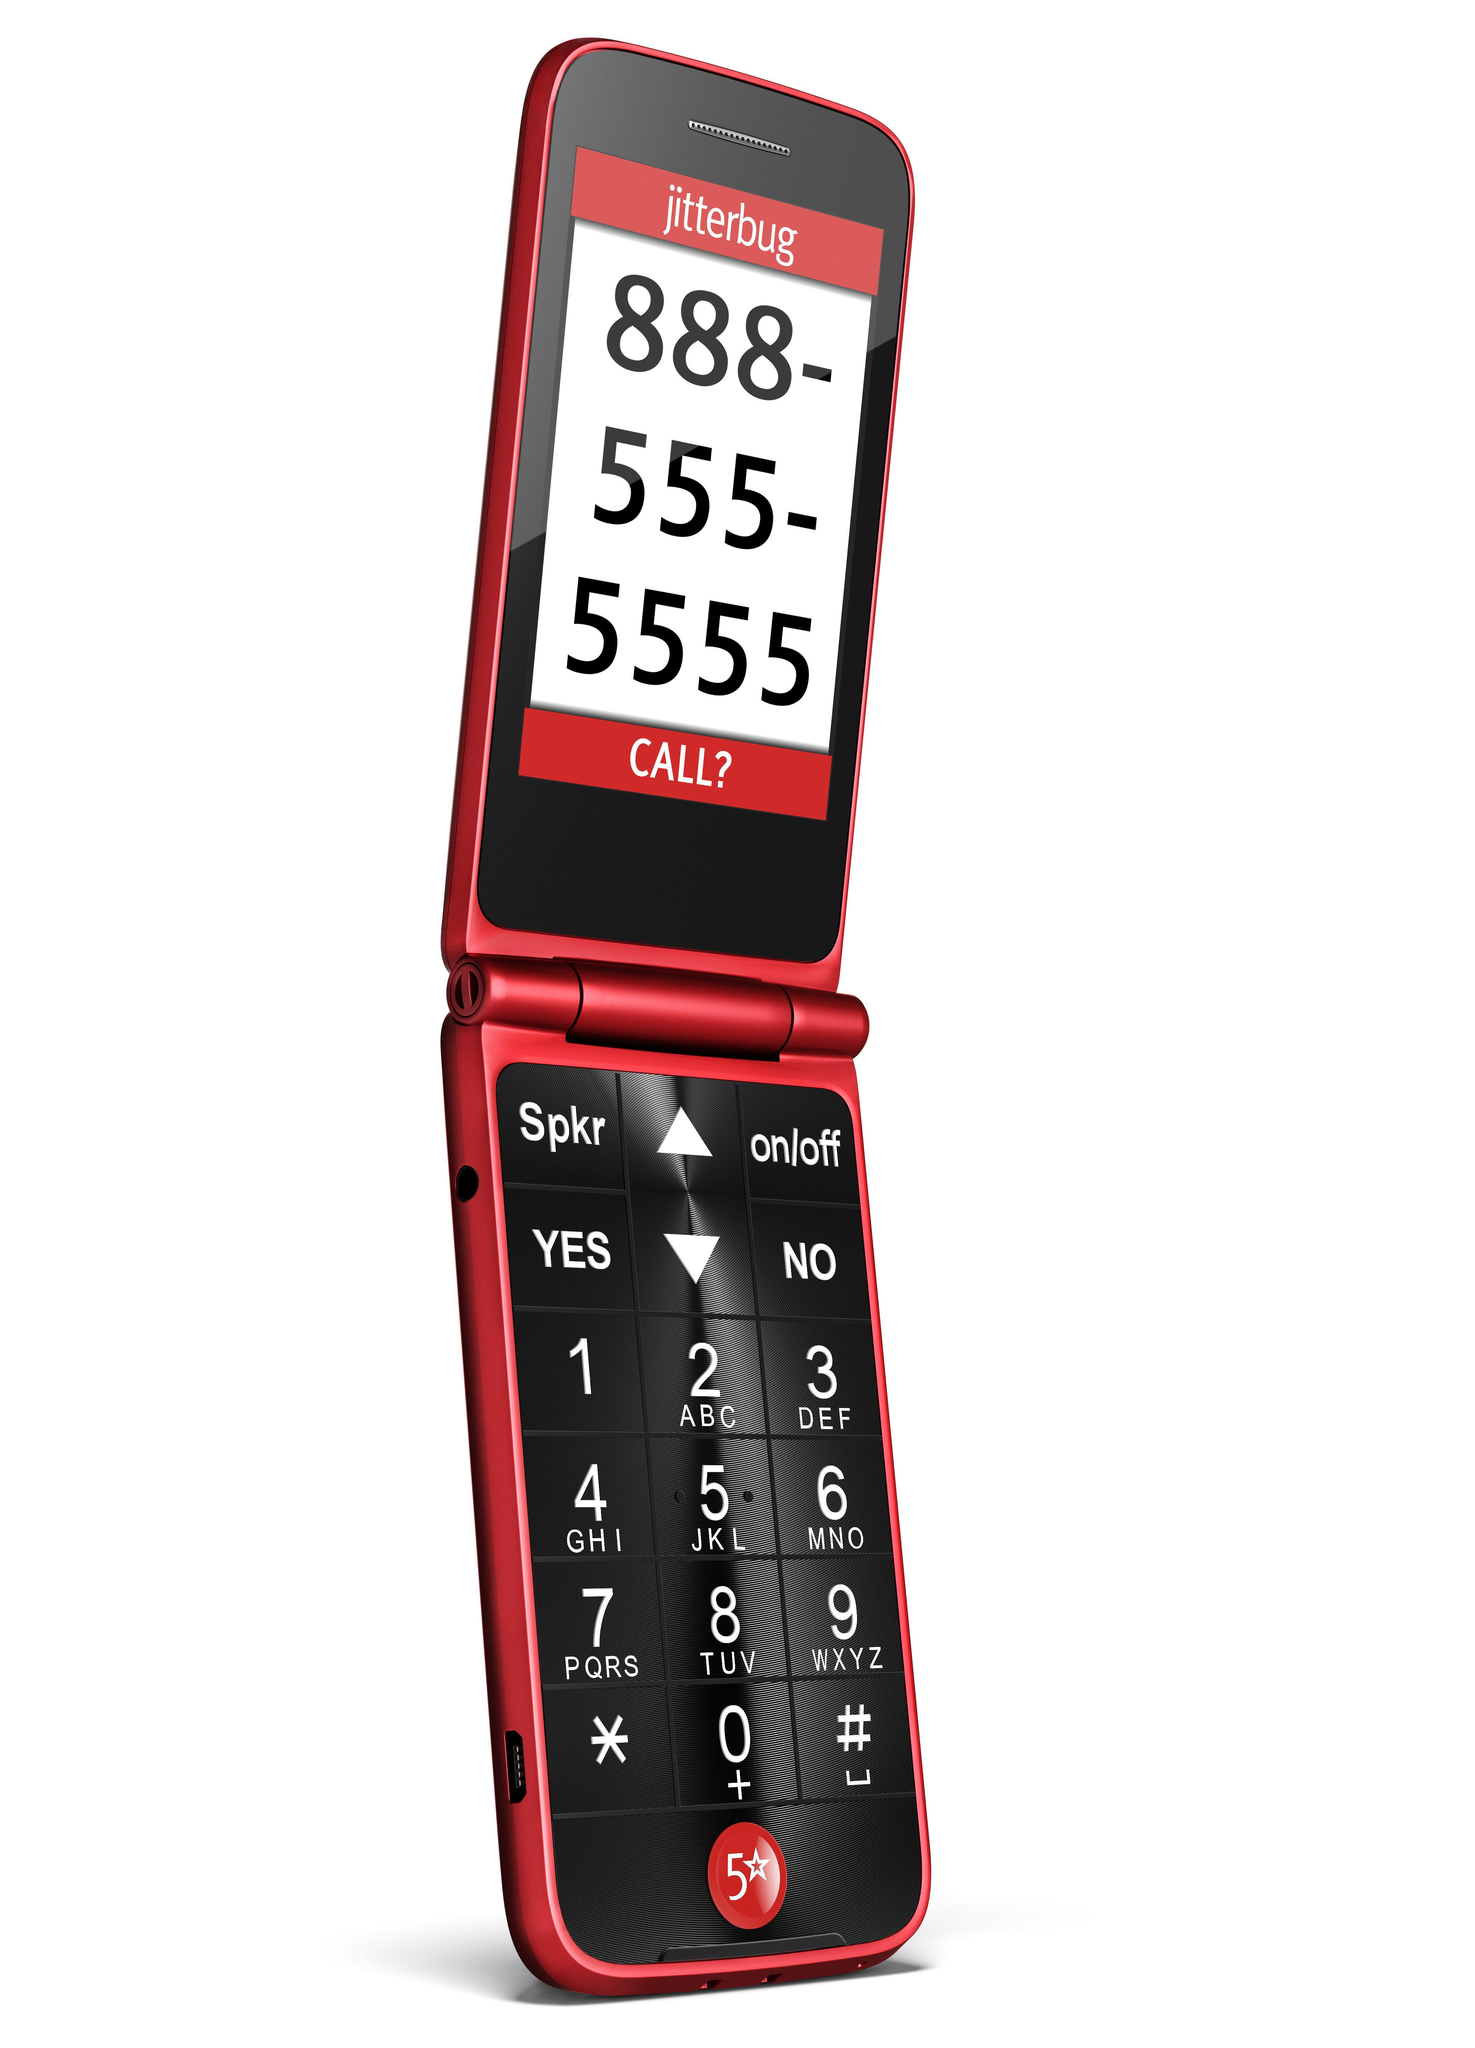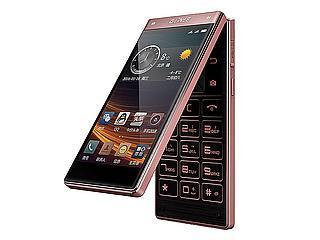The first image is the image on the left, the second image is the image on the right. Examine the images to the left and right. Is the description "Each phone is the same model" accurate? Answer yes or no. No. The first image is the image on the left, the second image is the image on the right. Evaluate the accuracy of this statement regarding the images: "One image shows a head-on open flip phone next to a closed phone, and the other image shows a single phone displayed upright and headon.". Is it true? Answer yes or no. No. 